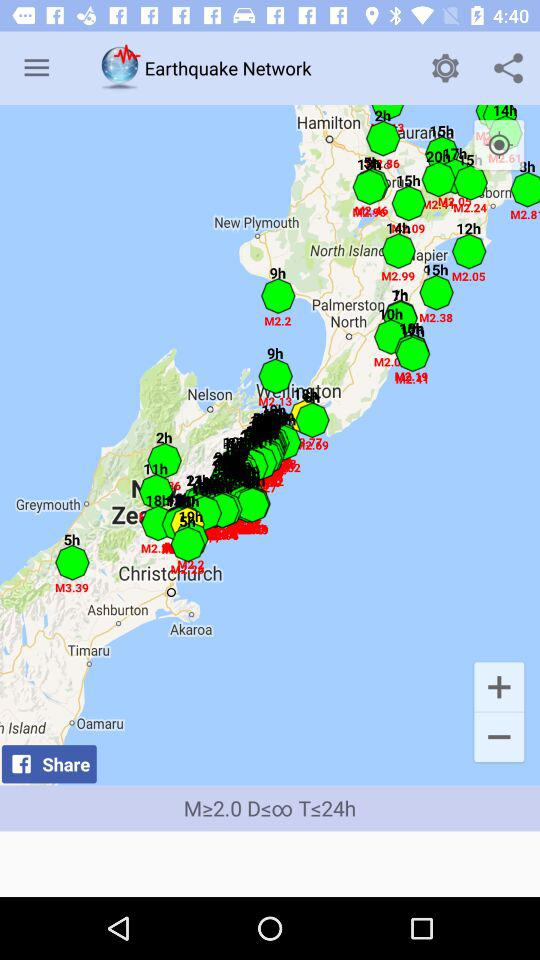Through what social media application can it be shared? You can share it through "Facebook". 